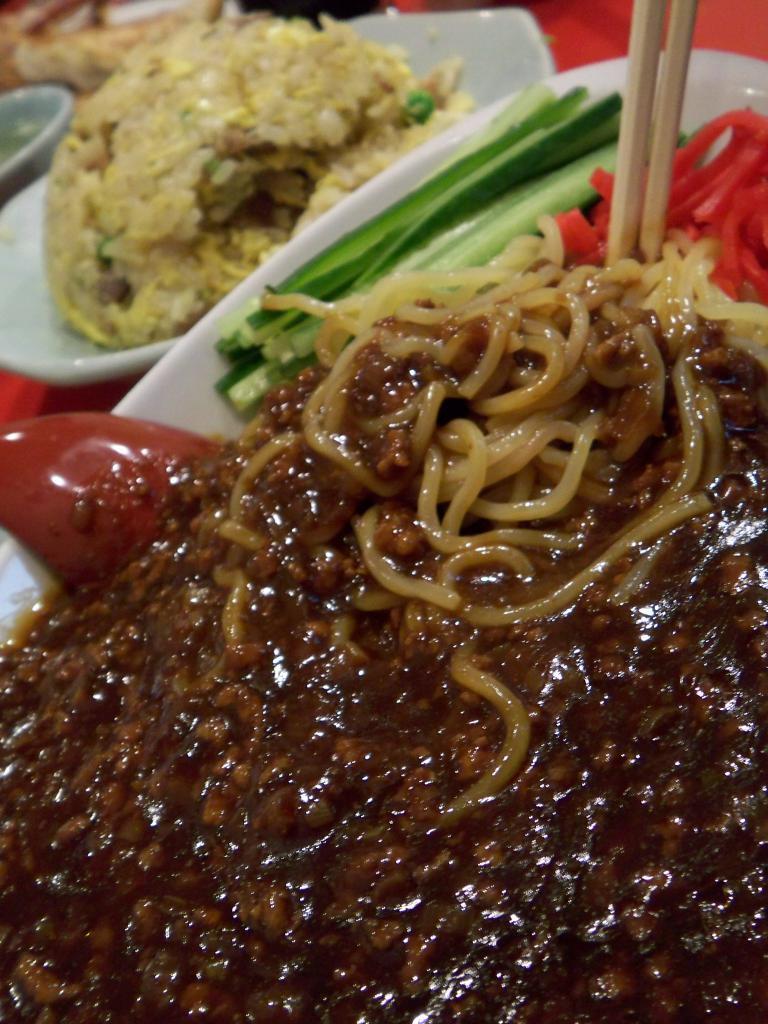Could you give a brief overview of what you see in this image? In this image we can see some food items and chopsticks. The background of the image is slightly blurred, where we can see some food items are kept on the white color plate. 